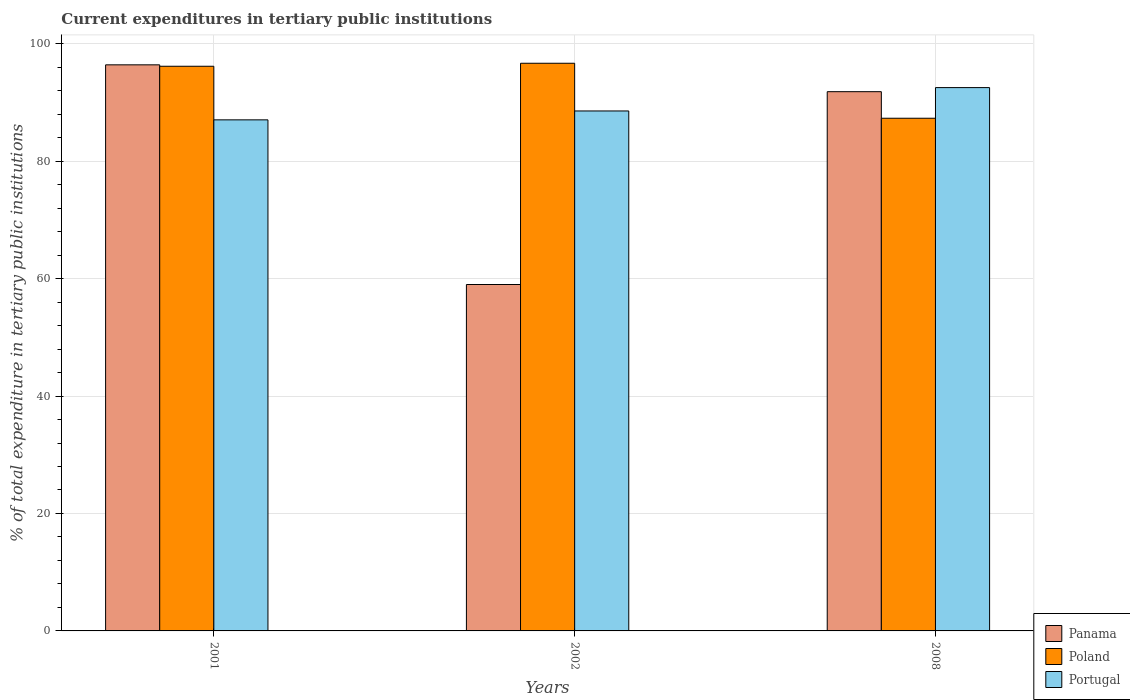How many bars are there on the 1st tick from the left?
Provide a succinct answer. 3. How many bars are there on the 3rd tick from the right?
Offer a very short reply. 3. What is the current expenditures in tertiary public institutions in Portugal in 2002?
Provide a succinct answer. 88.55. Across all years, what is the maximum current expenditures in tertiary public institutions in Poland?
Give a very brief answer. 96.67. Across all years, what is the minimum current expenditures in tertiary public institutions in Portugal?
Your answer should be very brief. 87.04. In which year was the current expenditures in tertiary public institutions in Panama maximum?
Your response must be concise. 2001. What is the total current expenditures in tertiary public institutions in Panama in the graph?
Your response must be concise. 247.23. What is the difference between the current expenditures in tertiary public institutions in Poland in 2001 and that in 2002?
Provide a short and direct response. -0.51. What is the difference between the current expenditures in tertiary public institutions in Poland in 2008 and the current expenditures in tertiary public institutions in Panama in 2001?
Your response must be concise. -9.09. What is the average current expenditures in tertiary public institutions in Portugal per year?
Offer a very short reply. 89.37. In the year 2001, what is the difference between the current expenditures in tertiary public institutions in Portugal and current expenditures in tertiary public institutions in Panama?
Provide a short and direct response. -9.37. In how many years, is the current expenditures in tertiary public institutions in Panama greater than 80 %?
Make the answer very short. 2. What is the ratio of the current expenditures in tertiary public institutions in Poland in 2001 to that in 2002?
Give a very brief answer. 0.99. What is the difference between the highest and the second highest current expenditures in tertiary public institutions in Poland?
Provide a short and direct response. 0.51. What is the difference between the highest and the lowest current expenditures in tertiary public institutions in Portugal?
Offer a very short reply. 5.49. In how many years, is the current expenditures in tertiary public institutions in Poland greater than the average current expenditures in tertiary public institutions in Poland taken over all years?
Your response must be concise. 2. What does the 2nd bar from the right in 2001 represents?
Offer a very short reply. Poland. Is it the case that in every year, the sum of the current expenditures in tertiary public institutions in Poland and current expenditures in tertiary public institutions in Portugal is greater than the current expenditures in tertiary public institutions in Panama?
Make the answer very short. Yes. How many bars are there?
Keep it short and to the point. 9. Are all the bars in the graph horizontal?
Keep it short and to the point. No. Are the values on the major ticks of Y-axis written in scientific E-notation?
Offer a terse response. No. Where does the legend appear in the graph?
Make the answer very short. Bottom right. What is the title of the graph?
Keep it short and to the point. Current expenditures in tertiary public institutions. Does "Fiji" appear as one of the legend labels in the graph?
Your answer should be compact. No. What is the label or title of the Y-axis?
Offer a terse response. % of total expenditure in tertiary public institutions. What is the % of total expenditure in tertiary public institutions in Panama in 2001?
Keep it short and to the point. 96.4. What is the % of total expenditure in tertiary public institutions of Poland in 2001?
Your response must be concise. 96.16. What is the % of total expenditure in tertiary public institutions of Portugal in 2001?
Offer a very short reply. 87.04. What is the % of total expenditure in tertiary public institutions in Panama in 2002?
Your answer should be compact. 58.99. What is the % of total expenditure in tertiary public institutions in Poland in 2002?
Ensure brevity in your answer.  96.67. What is the % of total expenditure in tertiary public institutions of Portugal in 2002?
Your answer should be very brief. 88.55. What is the % of total expenditure in tertiary public institutions in Panama in 2008?
Give a very brief answer. 91.83. What is the % of total expenditure in tertiary public institutions in Poland in 2008?
Offer a terse response. 87.31. What is the % of total expenditure in tertiary public institutions of Portugal in 2008?
Your answer should be compact. 92.53. Across all years, what is the maximum % of total expenditure in tertiary public institutions of Panama?
Offer a terse response. 96.4. Across all years, what is the maximum % of total expenditure in tertiary public institutions of Poland?
Offer a terse response. 96.67. Across all years, what is the maximum % of total expenditure in tertiary public institutions of Portugal?
Your response must be concise. 92.53. Across all years, what is the minimum % of total expenditure in tertiary public institutions of Panama?
Provide a succinct answer. 58.99. Across all years, what is the minimum % of total expenditure in tertiary public institutions of Poland?
Your answer should be very brief. 87.31. Across all years, what is the minimum % of total expenditure in tertiary public institutions of Portugal?
Your answer should be compact. 87.04. What is the total % of total expenditure in tertiary public institutions in Panama in the graph?
Your response must be concise. 247.23. What is the total % of total expenditure in tertiary public institutions of Poland in the graph?
Provide a short and direct response. 280.15. What is the total % of total expenditure in tertiary public institutions in Portugal in the graph?
Make the answer very short. 268.11. What is the difference between the % of total expenditure in tertiary public institutions of Panama in 2001 and that in 2002?
Your answer should be very brief. 37.41. What is the difference between the % of total expenditure in tertiary public institutions of Poland in 2001 and that in 2002?
Keep it short and to the point. -0.51. What is the difference between the % of total expenditure in tertiary public institutions in Portugal in 2001 and that in 2002?
Make the answer very short. -1.51. What is the difference between the % of total expenditure in tertiary public institutions in Panama in 2001 and that in 2008?
Provide a short and direct response. 4.57. What is the difference between the % of total expenditure in tertiary public institutions in Poland in 2001 and that in 2008?
Give a very brief answer. 8.85. What is the difference between the % of total expenditure in tertiary public institutions in Portugal in 2001 and that in 2008?
Your answer should be compact. -5.49. What is the difference between the % of total expenditure in tertiary public institutions of Panama in 2002 and that in 2008?
Ensure brevity in your answer.  -32.84. What is the difference between the % of total expenditure in tertiary public institutions in Poland in 2002 and that in 2008?
Offer a very short reply. 9.36. What is the difference between the % of total expenditure in tertiary public institutions of Portugal in 2002 and that in 2008?
Your response must be concise. -3.98. What is the difference between the % of total expenditure in tertiary public institutions of Panama in 2001 and the % of total expenditure in tertiary public institutions of Poland in 2002?
Provide a succinct answer. -0.27. What is the difference between the % of total expenditure in tertiary public institutions of Panama in 2001 and the % of total expenditure in tertiary public institutions of Portugal in 2002?
Make the answer very short. 7.85. What is the difference between the % of total expenditure in tertiary public institutions in Poland in 2001 and the % of total expenditure in tertiary public institutions in Portugal in 2002?
Ensure brevity in your answer.  7.61. What is the difference between the % of total expenditure in tertiary public institutions of Panama in 2001 and the % of total expenditure in tertiary public institutions of Poland in 2008?
Offer a terse response. 9.09. What is the difference between the % of total expenditure in tertiary public institutions of Panama in 2001 and the % of total expenditure in tertiary public institutions of Portugal in 2008?
Provide a short and direct response. 3.88. What is the difference between the % of total expenditure in tertiary public institutions in Poland in 2001 and the % of total expenditure in tertiary public institutions in Portugal in 2008?
Your answer should be compact. 3.64. What is the difference between the % of total expenditure in tertiary public institutions of Panama in 2002 and the % of total expenditure in tertiary public institutions of Poland in 2008?
Ensure brevity in your answer.  -28.32. What is the difference between the % of total expenditure in tertiary public institutions in Panama in 2002 and the % of total expenditure in tertiary public institutions in Portugal in 2008?
Your answer should be compact. -33.53. What is the difference between the % of total expenditure in tertiary public institutions in Poland in 2002 and the % of total expenditure in tertiary public institutions in Portugal in 2008?
Ensure brevity in your answer.  4.15. What is the average % of total expenditure in tertiary public institutions of Panama per year?
Provide a succinct answer. 82.41. What is the average % of total expenditure in tertiary public institutions in Poland per year?
Your response must be concise. 93.38. What is the average % of total expenditure in tertiary public institutions in Portugal per year?
Offer a very short reply. 89.37. In the year 2001, what is the difference between the % of total expenditure in tertiary public institutions of Panama and % of total expenditure in tertiary public institutions of Poland?
Provide a succinct answer. 0.24. In the year 2001, what is the difference between the % of total expenditure in tertiary public institutions in Panama and % of total expenditure in tertiary public institutions in Portugal?
Provide a short and direct response. 9.37. In the year 2001, what is the difference between the % of total expenditure in tertiary public institutions in Poland and % of total expenditure in tertiary public institutions in Portugal?
Offer a terse response. 9.13. In the year 2002, what is the difference between the % of total expenditure in tertiary public institutions in Panama and % of total expenditure in tertiary public institutions in Poland?
Your answer should be compact. -37.68. In the year 2002, what is the difference between the % of total expenditure in tertiary public institutions in Panama and % of total expenditure in tertiary public institutions in Portugal?
Provide a succinct answer. -29.55. In the year 2002, what is the difference between the % of total expenditure in tertiary public institutions of Poland and % of total expenditure in tertiary public institutions of Portugal?
Your answer should be compact. 8.12. In the year 2008, what is the difference between the % of total expenditure in tertiary public institutions of Panama and % of total expenditure in tertiary public institutions of Poland?
Your response must be concise. 4.52. In the year 2008, what is the difference between the % of total expenditure in tertiary public institutions of Panama and % of total expenditure in tertiary public institutions of Portugal?
Provide a short and direct response. -0.69. In the year 2008, what is the difference between the % of total expenditure in tertiary public institutions of Poland and % of total expenditure in tertiary public institutions of Portugal?
Your answer should be compact. -5.22. What is the ratio of the % of total expenditure in tertiary public institutions of Panama in 2001 to that in 2002?
Make the answer very short. 1.63. What is the ratio of the % of total expenditure in tertiary public institutions of Poland in 2001 to that in 2002?
Offer a terse response. 0.99. What is the ratio of the % of total expenditure in tertiary public institutions of Portugal in 2001 to that in 2002?
Your response must be concise. 0.98. What is the ratio of the % of total expenditure in tertiary public institutions in Panama in 2001 to that in 2008?
Provide a short and direct response. 1.05. What is the ratio of the % of total expenditure in tertiary public institutions of Poland in 2001 to that in 2008?
Offer a very short reply. 1.1. What is the ratio of the % of total expenditure in tertiary public institutions of Portugal in 2001 to that in 2008?
Provide a short and direct response. 0.94. What is the ratio of the % of total expenditure in tertiary public institutions of Panama in 2002 to that in 2008?
Your answer should be compact. 0.64. What is the ratio of the % of total expenditure in tertiary public institutions in Poland in 2002 to that in 2008?
Your answer should be very brief. 1.11. What is the ratio of the % of total expenditure in tertiary public institutions in Portugal in 2002 to that in 2008?
Make the answer very short. 0.96. What is the difference between the highest and the second highest % of total expenditure in tertiary public institutions of Panama?
Give a very brief answer. 4.57. What is the difference between the highest and the second highest % of total expenditure in tertiary public institutions of Poland?
Your answer should be very brief. 0.51. What is the difference between the highest and the second highest % of total expenditure in tertiary public institutions of Portugal?
Ensure brevity in your answer.  3.98. What is the difference between the highest and the lowest % of total expenditure in tertiary public institutions in Panama?
Your answer should be very brief. 37.41. What is the difference between the highest and the lowest % of total expenditure in tertiary public institutions of Poland?
Offer a terse response. 9.36. What is the difference between the highest and the lowest % of total expenditure in tertiary public institutions in Portugal?
Offer a very short reply. 5.49. 